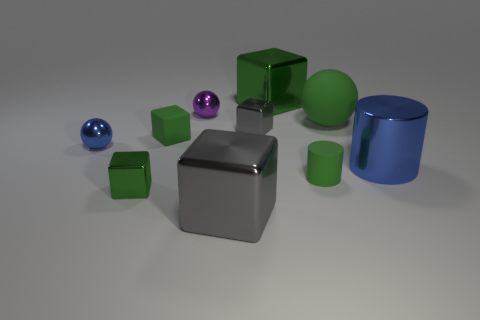The cylinder that is the same color as the big ball is what size?
Keep it short and to the point. Small. How many cylinders are big gray things or big blue things?
Offer a terse response. 1. There is a small matte thing in front of the blue cylinder; are there any cylinders that are right of it?
Offer a terse response. Yes. Does the purple thing have the same shape as the big green object on the right side of the green matte cylinder?
Your response must be concise. Yes. How many other objects are the same size as the purple metallic sphere?
Make the answer very short. 5. How many brown things are either big spheres or large rubber cylinders?
Offer a terse response. 0. How many large blocks are both in front of the blue cylinder and behind the large gray metallic cube?
Offer a terse response. 0. The blue object on the right side of the gray shiny block to the right of the large metallic block that is in front of the rubber ball is made of what material?
Provide a succinct answer. Metal. How many small blue things are the same material as the green cylinder?
Give a very brief answer. 0. There is a small metal object that is the same color as the large cylinder; what shape is it?
Provide a succinct answer. Sphere. 